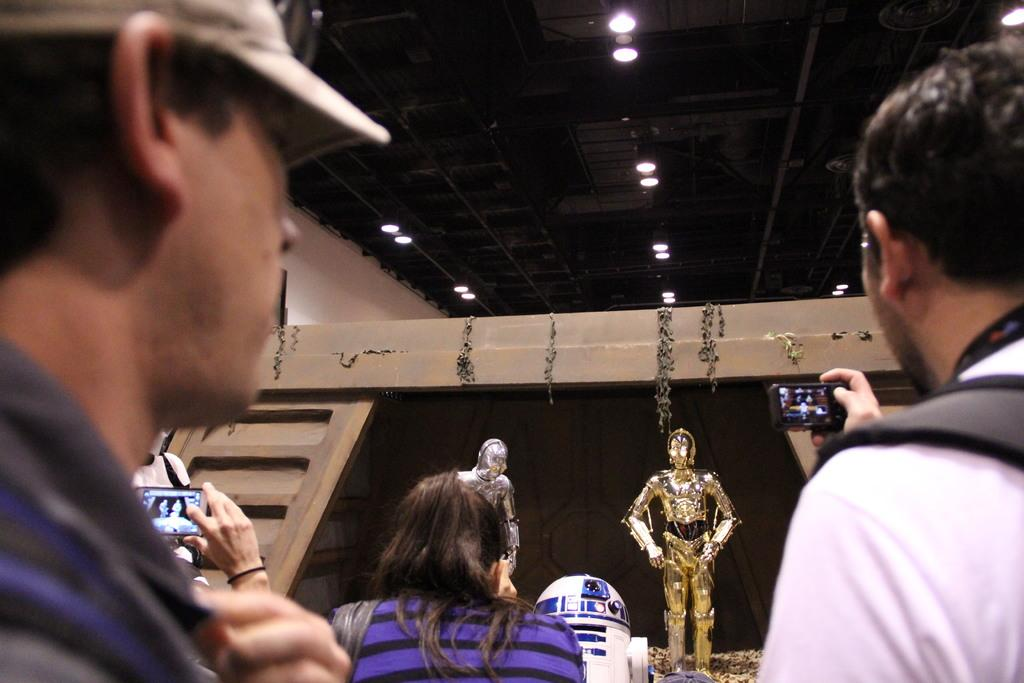What is the person in the image doing? The person in the image is capturing a photograph. What is the subject of the photograph? The subject of the photograph is robots. Can you describe the people on the left side of the image? There are a few persons on the left side of the image. What type of lighting is present in the image? Ceiling lights are visible at the top of the image. What part of a building can be seen in the image? The image includes a roof. How many women are present in the image? There is no mention of women in the image. 